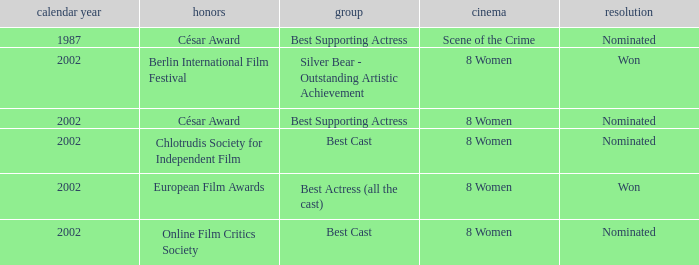What was the categorie in 2002 at the Berlin international Film Festival that Danielle Darrieux was in? Silver Bear - Outstanding Artistic Achievement. 